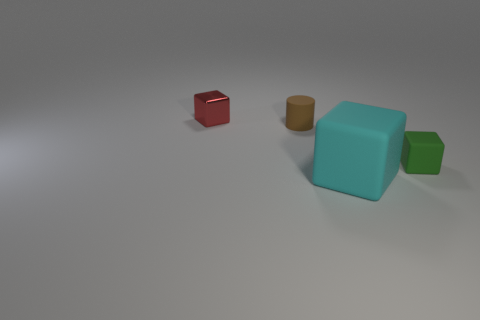Subtract all tiny red shiny cubes. How many cubes are left? 2 Add 3 small brown objects. How many objects exist? 7 Subtract all red cubes. How many cubes are left? 2 Subtract all cylinders. How many objects are left? 3 Subtract all brown cylinders. How many purple cubes are left? 0 Subtract 0 gray balls. How many objects are left? 4 Subtract all purple blocks. Subtract all purple cylinders. How many blocks are left? 3 Subtract all big cyan rubber blocks. Subtract all small brown cylinders. How many objects are left? 2 Add 2 metallic cubes. How many metallic cubes are left? 3 Add 2 big cyan blocks. How many big cyan blocks exist? 3 